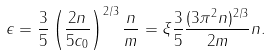<formula> <loc_0><loc_0><loc_500><loc_500>\epsilon = \frac { 3 } { 5 } \left ( \frac { 2 n } { 5 c _ { 0 } } \right ) ^ { 2 / 3 } \frac { n } { m } = \xi \frac { 3 } { 5 } \frac { ( 3 \pi ^ { 2 } n ) ^ { 2 / 3 } } { 2 m } n .</formula> 